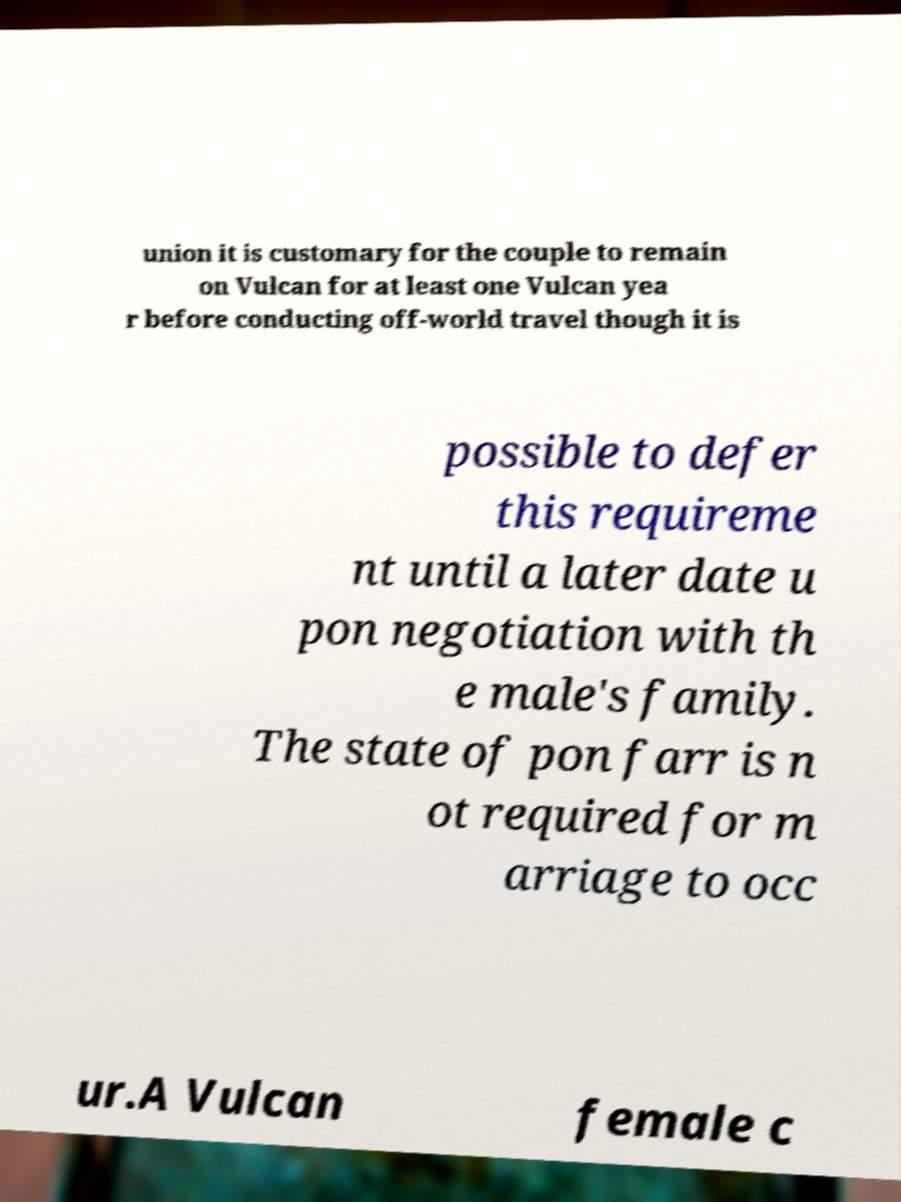For documentation purposes, I need the text within this image transcribed. Could you provide that? union it is customary for the couple to remain on Vulcan for at least one Vulcan yea r before conducting off-world travel though it is possible to defer this requireme nt until a later date u pon negotiation with th e male's family. The state of pon farr is n ot required for m arriage to occ ur.A Vulcan female c 